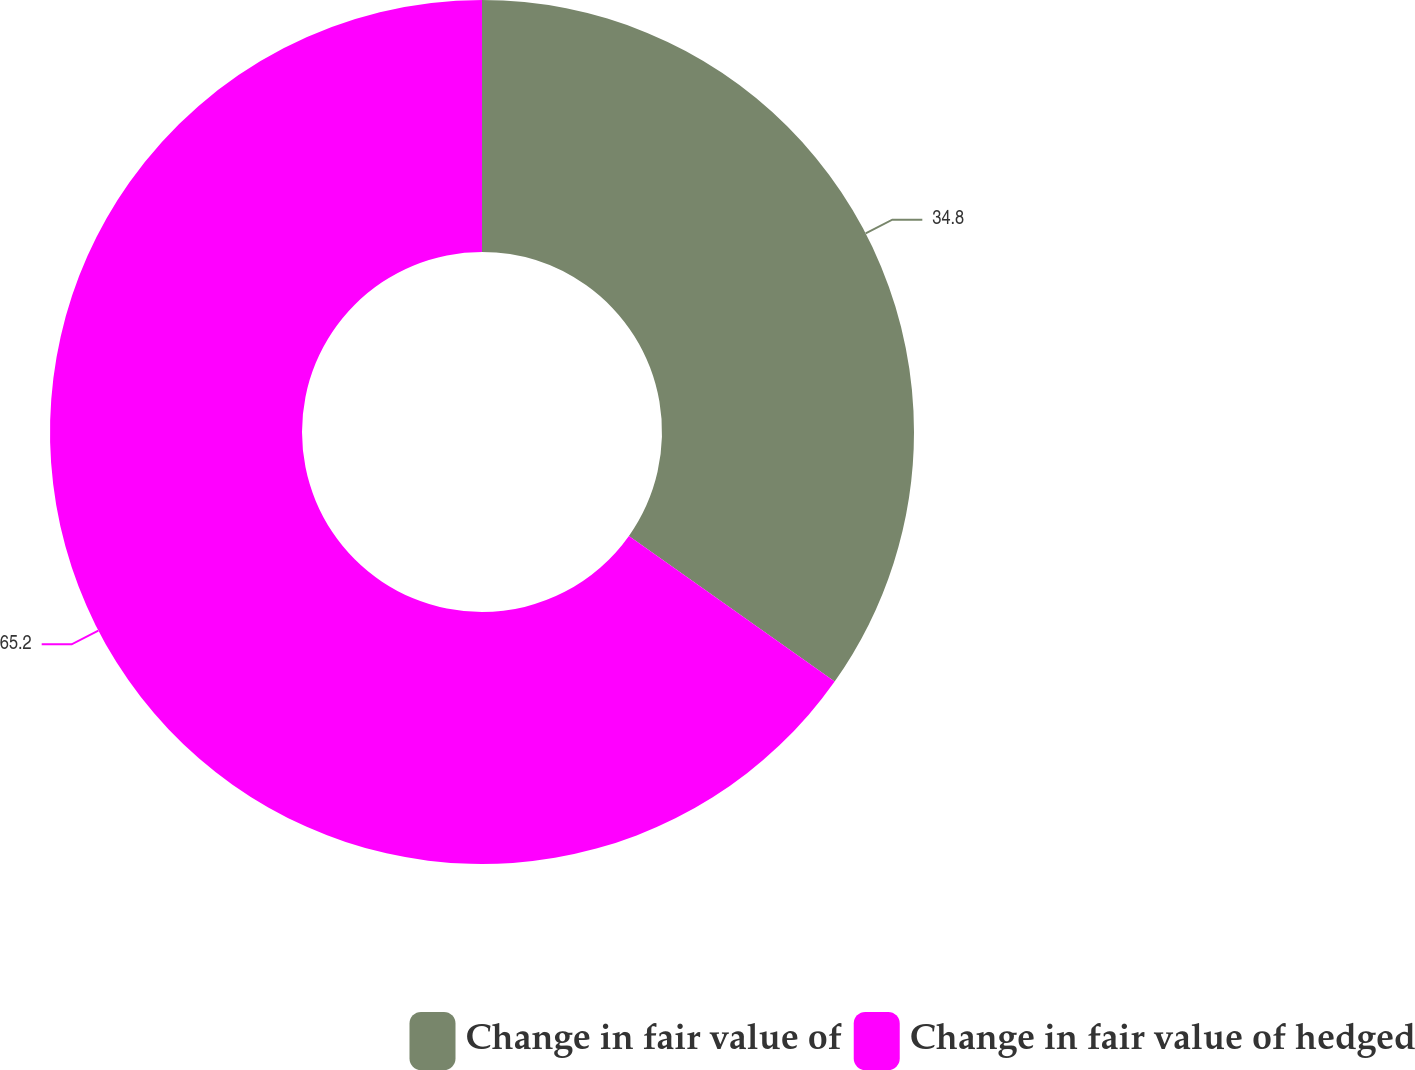Convert chart to OTSL. <chart><loc_0><loc_0><loc_500><loc_500><pie_chart><fcel>Change in fair value of<fcel>Change in fair value of hedged<nl><fcel>34.8%<fcel>65.2%<nl></chart> 